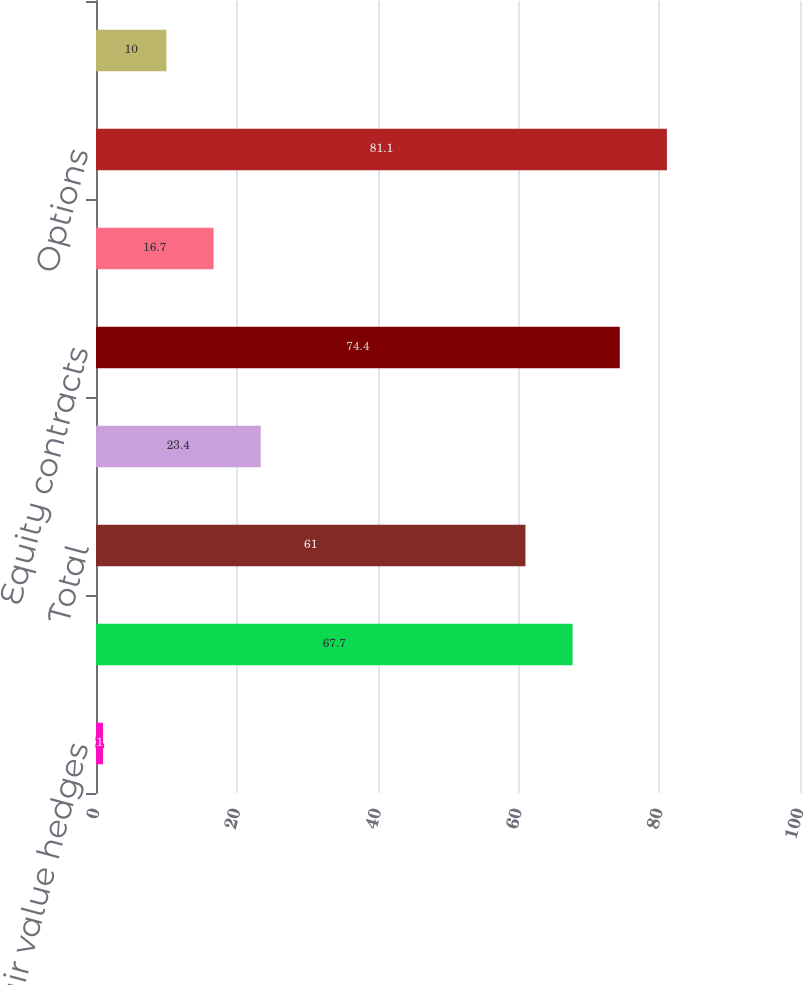<chart> <loc_0><loc_0><loc_500><loc_500><bar_chart><fcel>Fair value hedges<fcel>Cash flow hedges<fcel>Total<fcel>Interest rate contracts<fcel>Equity contracts<fcel>Credit derivatives<fcel>Options<fcel>Commitments related to<nl><fcel>1<fcel>67.7<fcel>61<fcel>23.4<fcel>74.4<fcel>16.7<fcel>81.1<fcel>10<nl></chart> 